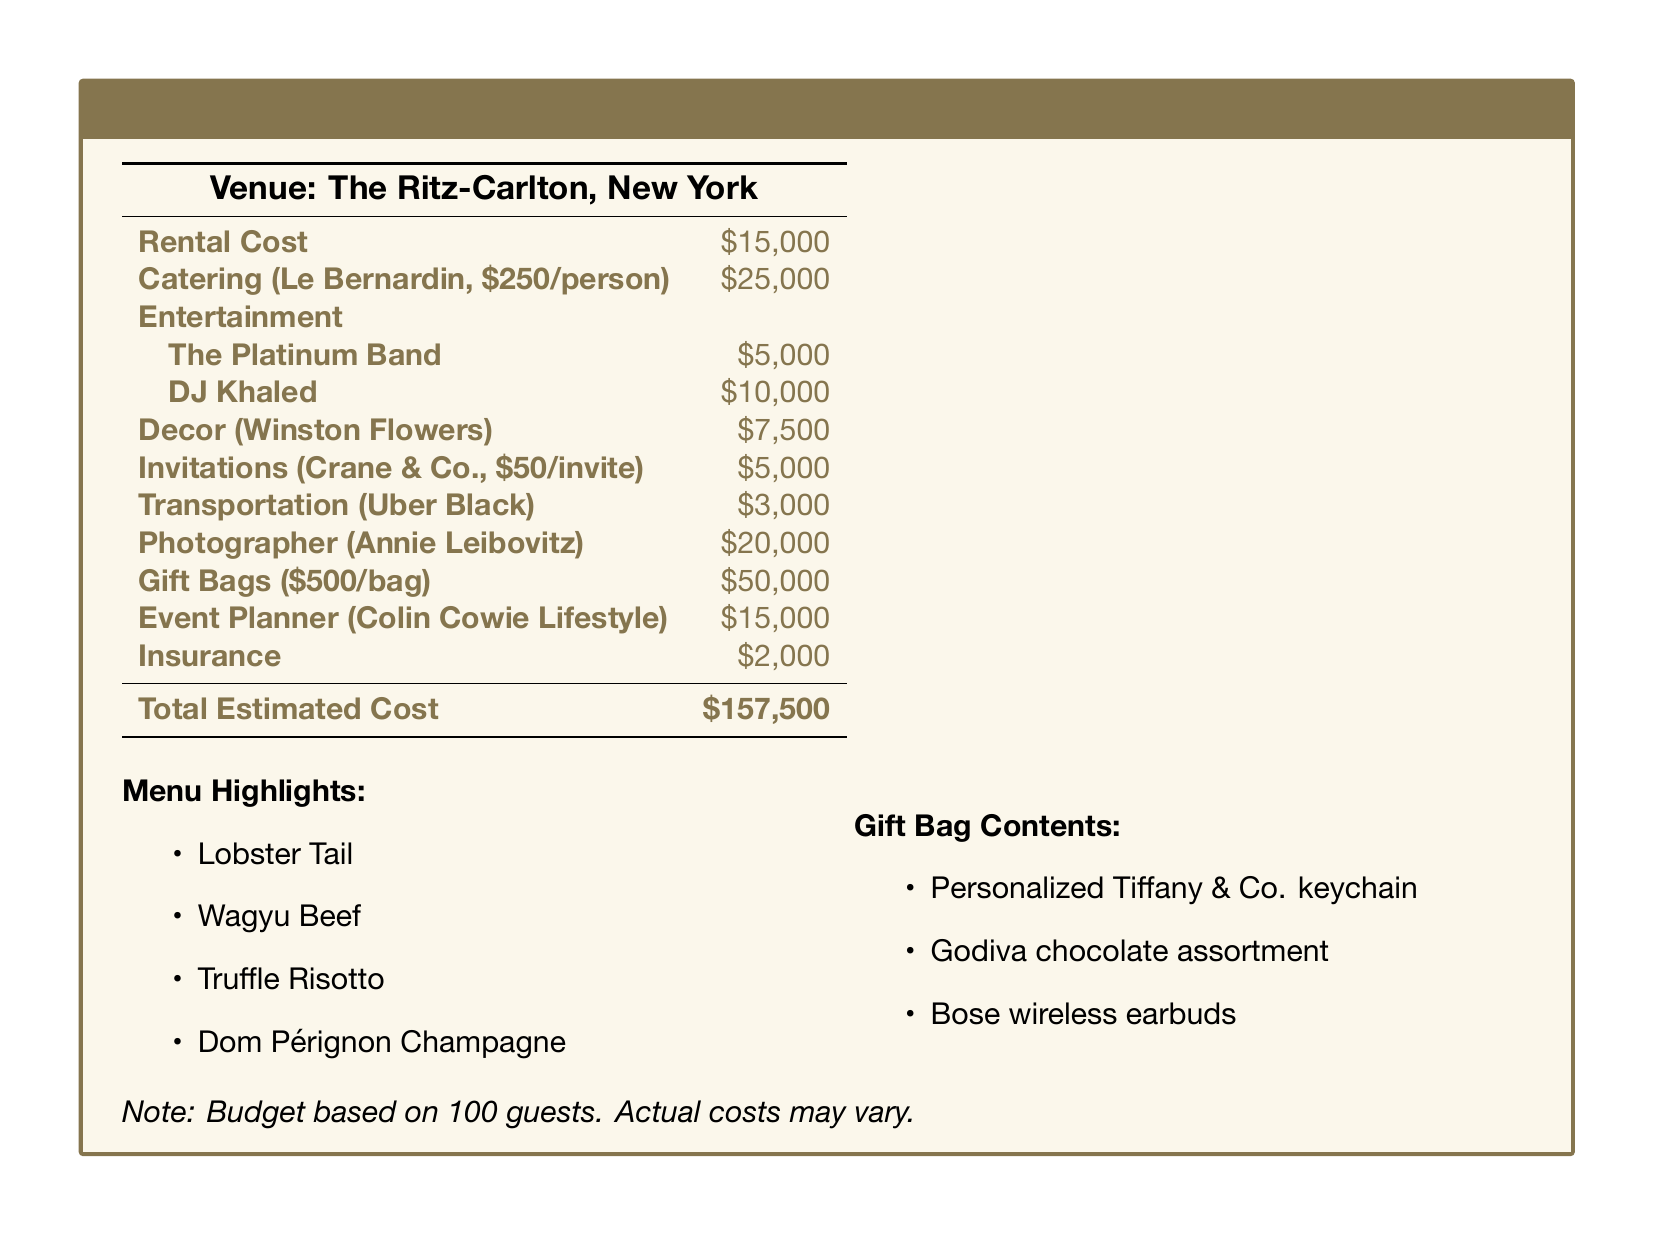What is the venue for the reunion party? The venue is specified as The Ritz-Carlton, New York.
Answer: The Ritz-Carlton, New York What is the total estimated cost of the party? The total estimated cost is listed in the budget section of the document.
Answer: $157,500 How much does catering per person cost? The catering cost per person is provided under the Catering section.
Answer: $250/person Who is the photographer for the event? The photographer's name is mentioned in the budget document.
Answer: Annie Leibovitz What is the cost of the DJ? The cost for the entertainment provided by the DJ is outlined in the document.
Answer: $10,000 How many guests is the budget based on? The document specifies the number of guests considered for the budget.
Answer: 100 guests What is included in the gift bags? The document lists specific contents of the gift bags.
Answer: Personalized Tiffany & Co. keychain, Godiva chocolate assortment, Bose wireless earbuds How much is allocated for gift bags? The budget section reveals the total cost for gift bags.
Answer: $50,000 What type of champagne is featured in the menu highlights? The menu highlights mention a specific variety of champagne.
Answer: Dom Pérignon Champagne 